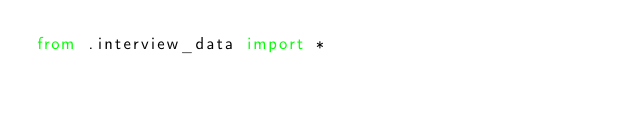<code> <loc_0><loc_0><loc_500><loc_500><_Python_>from .interview_data import *</code> 